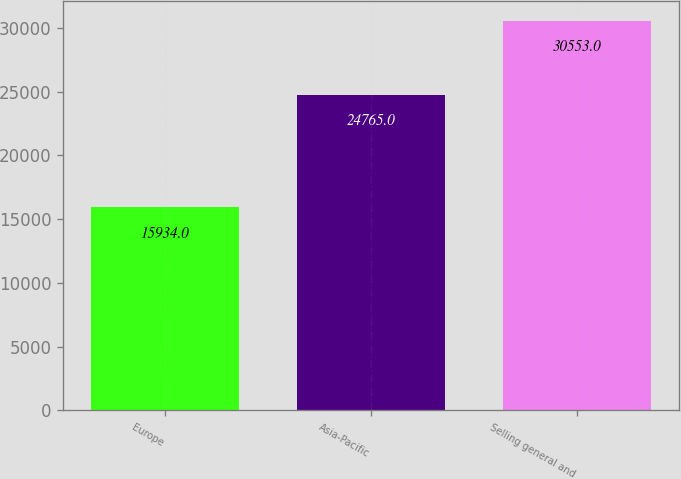Convert chart to OTSL. <chart><loc_0><loc_0><loc_500><loc_500><bar_chart><fcel>Europe<fcel>Asia-Pacific<fcel>Selling general and<nl><fcel>15934<fcel>24765<fcel>30553<nl></chart> 